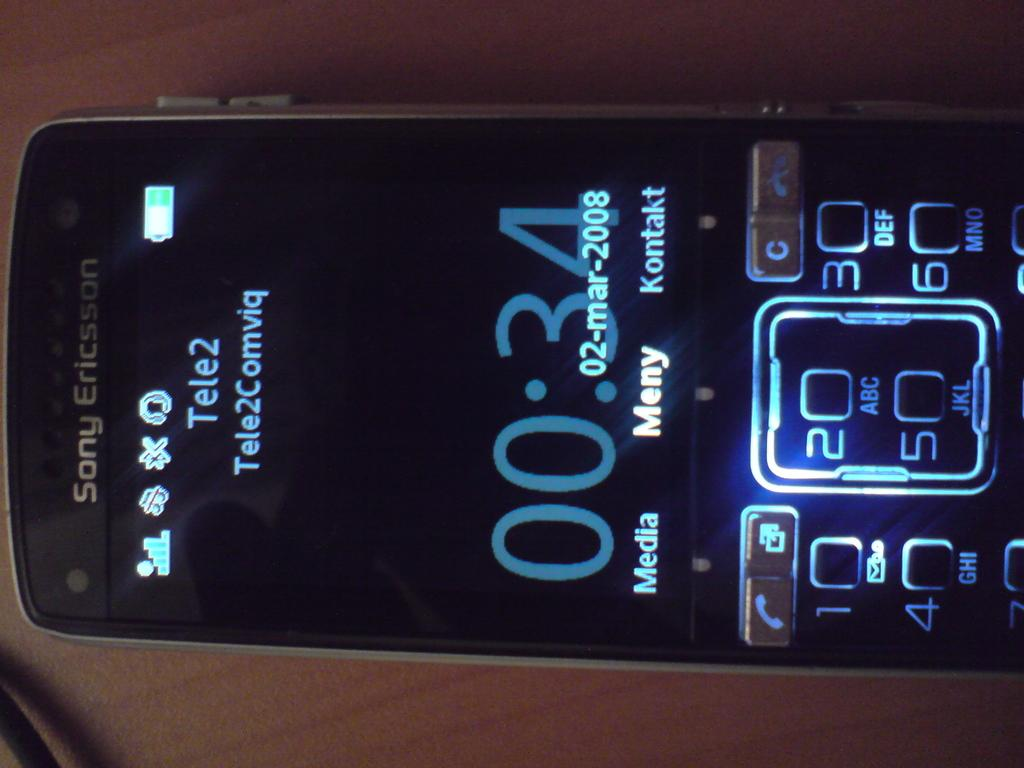<image>
Provide a brief description of the given image. the front screen of a sony ericsson phone, with meny selected 